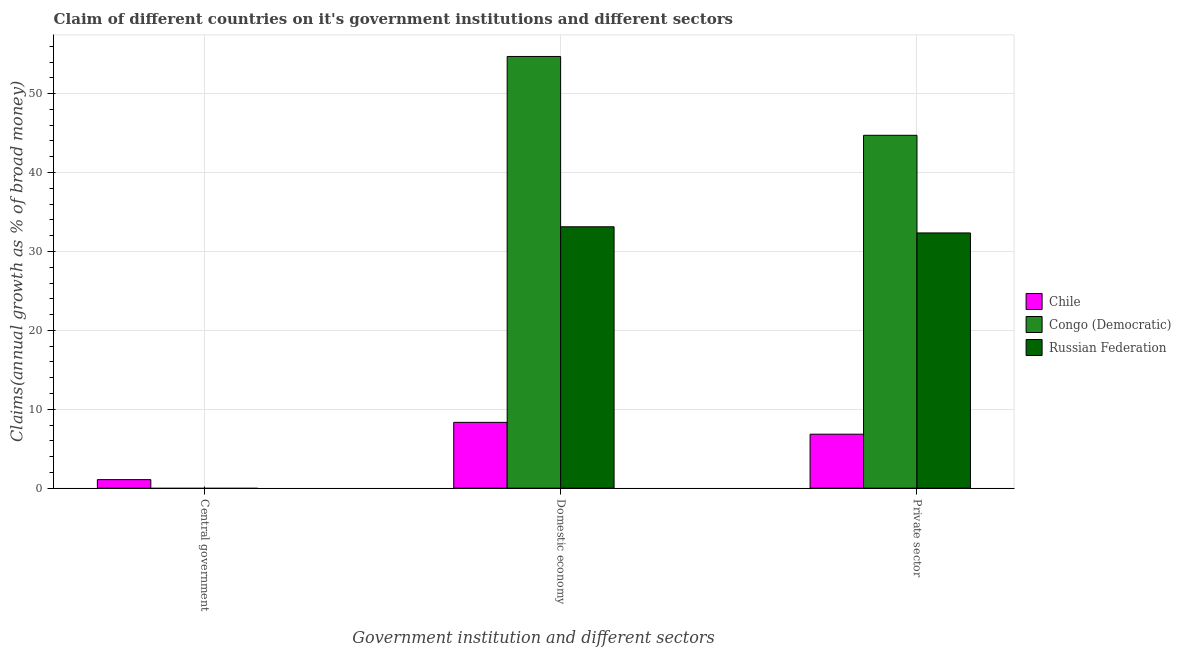Are the number of bars per tick equal to the number of legend labels?
Make the answer very short. No. What is the label of the 2nd group of bars from the left?
Provide a short and direct response. Domestic economy. What is the percentage of claim on the central government in Russian Federation?
Provide a short and direct response. 0. Across all countries, what is the maximum percentage of claim on the private sector?
Offer a very short reply. 44.72. In which country was the percentage of claim on the domestic economy maximum?
Provide a succinct answer. Congo (Democratic). What is the total percentage of claim on the domestic economy in the graph?
Your response must be concise. 96.18. What is the difference between the percentage of claim on the domestic economy in Chile and that in Congo (Democratic)?
Offer a very short reply. -46.37. What is the difference between the percentage of claim on the central government in Russian Federation and the percentage of claim on the domestic economy in Congo (Democratic)?
Your answer should be compact. -54.71. What is the average percentage of claim on the domestic economy per country?
Your response must be concise. 32.06. What is the difference between the percentage of claim on the private sector and percentage of claim on the central government in Chile?
Give a very brief answer. 5.76. In how many countries, is the percentage of claim on the central government greater than 48 %?
Keep it short and to the point. 0. What is the ratio of the percentage of claim on the domestic economy in Russian Federation to that in Congo (Democratic)?
Your answer should be very brief. 0.61. What is the difference between the highest and the second highest percentage of claim on the private sector?
Ensure brevity in your answer.  12.38. What is the difference between the highest and the lowest percentage of claim on the domestic economy?
Give a very brief answer. 46.37. Is the sum of the percentage of claim on the domestic economy in Congo (Democratic) and Russian Federation greater than the maximum percentage of claim on the central government across all countries?
Make the answer very short. Yes. Are all the bars in the graph horizontal?
Offer a very short reply. No. Does the graph contain any zero values?
Provide a succinct answer. Yes. Does the graph contain grids?
Your answer should be compact. Yes. Where does the legend appear in the graph?
Keep it short and to the point. Center right. How are the legend labels stacked?
Your answer should be very brief. Vertical. What is the title of the graph?
Offer a very short reply. Claim of different countries on it's government institutions and different sectors. What is the label or title of the X-axis?
Your response must be concise. Government institution and different sectors. What is the label or title of the Y-axis?
Your answer should be compact. Claims(annual growth as % of broad money). What is the Claims(annual growth as % of broad money) in Chile in Central government?
Provide a short and direct response. 1.08. What is the Claims(annual growth as % of broad money) in Congo (Democratic) in Central government?
Provide a short and direct response. 0. What is the Claims(annual growth as % of broad money) in Russian Federation in Central government?
Make the answer very short. 0. What is the Claims(annual growth as % of broad money) of Chile in Domestic economy?
Give a very brief answer. 8.34. What is the Claims(annual growth as % of broad money) in Congo (Democratic) in Domestic economy?
Your response must be concise. 54.71. What is the Claims(annual growth as % of broad money) in Russian Federation in Domestic economy?
Make the answer very short. 33.13. What is the Claims(annual growth as % of broad money) of Chile in Private sector?
Provide a succinct answer. 6.84. What is the Claims(annual growth as % of broad money) in Congo (Democratic) in Private sector?
Ensure brevity in your answer.  44.72. What is the Claims(annual growth as % of broad money) of Russian Federation in Private sector?
Offer a terse response. 32.34. Across all Government institution and different sectors, what is the maximum Claims(annual growth as % of broad money) in Chile?
Offer a terse response. 8.34. Across all Government institution and different sectors, what is the maximum Claims(annual growth as % of broad money) of Congo (Democratic)?
Your answer should be compact. 54.71. Across all Government institution and different sectors, what is the maximum Claims(annual growth as % of broad money) of Russian Federation?
Ensure brevity in your answer.  33.13. Across all Government institution and different sectors, what is the minimum Claims(annual growth as % of broad money) of Chile?
Ensure brevity in your answer.  1.08. Across all Government institution and different sectors, what is the minimum Claims(annual growth as % of broad money) of Congo (Democratic)?
Provide a short and direct response. 0. What is the total Claims(annual growth as % of broad money) of Chile in the graph?
Ensure brevity in your answer.  16.26. What is the total Claims(annual growth as % of broad money) in Congo (Democratic) in the graph?
Offer a terse response. 99.43. What is the total Claims(annual growth as % of broad money) in Russian Federation in the graph?
Your answer should be very brief. 65.47. What is the difference between the Claims(annual growth as % of broad money) of Chile in Central government and that in Domestic economy?
Your response must be concise. -7.26. What is the difference between the Claims(annual growth as % of broad money) in Chile in Central government and that in Private sector?
Provide a succinct answer. -5.76. What is the difference between the Claims(annual growth as % of broad money) of Chile in Domestic economy and that in Private sector?
Offer a terse response. 1.5. What is the difference between the Claims(annual growth as % of broad money) in Congo (Democratic) in Domestic economy and that in Private sector?
Offer a terse response. 9.99. What is the difference between the Claims(annual growth as % of broad money) in Russian Federation in Domestic economy and that in Private sector?
Your answer should be compact. 0.78. What is the difference between the Claims(annual growth as % of broad money) in Chile in Central government and the Claims(annual growth as % of broad money) in Congo (Democratic) in Domestic economy?
Provide a succinct answer. -53.63. What is the difference between the Claims(annual growth as % of broad money) in Chile in Central government and the Claims(annual growth as % of broad money) in Russian Federation in Domestic economy?
Your answer should be compact. -32.05. What is the difference between the Claims(annual growth as % of broad money) in Chile in Central government and the Claims(annual growth as % of broad money) in Congo (Democratic) in Private sector?
Make the answer very short. -43.64. What is the difference between the Claims(annual growth as % of broad money) in Chile in Central government and the Claims(annual growth as % of broad money) in Russian Federation in Private sector?
Keep it short and to the point. -31.26. What is the difference between the Claims(annual growth as % of broad money) of Chile in Domestic economy and the Claims(annual growth as % of broad money) of Congo (Democratic) in Private sector?
Your answer should be very brief. -36.38. What is the difference between the Claims(annual growth as % of broad money) in Chile in Domestic economy and the Claims(annual growth as % of broad money) in Russian Federation in Private sector?
Ensure brevity in your answer.  -24.01. What is the difference between the Claims(annual growth as % of broad money) of Congo (Democratic) in Domestic economy and the Claims(annual growth as % of broad money) of Russian Federation in Private sector?
Offer a terse response. 22.37. What is the average Claims(annual growth as % of broad money) in Chile per Government institution and different sectors?
Make the answer very short. 5.42. What is the average Claims(annual growth as % of broad money) in Congo (Democratic) per Government institution and different sectors?
Ensure brevity in your answer.  33.14. What is the average Claims(annual growth as % of broad money) in Russian Federation per Government institution and different sectors?
Provide a succinct answer. 21.82. What is the difference between the Claims(annual growth as % of broad money) in Chile and Claims(annual growth as % of broad money) in Congo (Democratic) in Domestic economy?
Ensure brevity in your answer.  -46.37. What is the difference between the Claims(annual growth as % of broad money) of Chile and Claims(annual growth as % of broad money) of Russian Federation in Domestic economy?
Provide a succinct answer. -24.79. What is the difference between the Claims(annual growth as % of broad money) of Congo (Democratic) and Claims(annual growth as % of broad money) of Russian Federation in Domestic economy?
Offer a terse response. 21.59. What is the difference between the Claims(annual growth as % of broad money) in Chile and Claims(annual growth as % of broad money) in Congo (Democratic) in Private sector?
Provide a succinct answer. -37.88. What is the difference between the Claims(annual growth as % of broad money) in Chile and Claims(annual growth as % of broad money) in Russian Federation in Private sector?
Provide a succinct answer. -25.51. What is the difference between the Claims(annual growth as % of broad money) of Congo (Democratic) and Claims(annual growth as % of broad money) of Russian Federation in Private sector?
Offer a terse response. 12.38. What is the ratio of the Claims(annual growth as % of broad money) of Chile in Central government to that in Domestic economy?
Your answer should be compact. 0.13. What is the ratio of the Claims(annual growth as % of broad money) of Chile in Central government to that in Private sector?
Your response must be concise. 0.16. What is the ratio of the Claims(annual growth as % of broad money) in Chile in Domestic economy to that in Private sector?
Give a very brief answer. 1.22. What is the ratio of the Claims(annual growth as % of broad money) in Congo (Democratic) in Domestic economy to that in Private sector?
Offer a terse response. 1.22. What is the ratio of the Claims(annual growth as % of broad money) of Russian Federation in Domestic economy to that in Private sector?
Ensure brevity in your answer.  1.02. What is the difference between the highest and the second highest Claims(annual growth as % of broad money) in Chile?
Provide a succinct answer. 1.5. What is the difference between the highest and the lowest Claims(annual growth as % of broad money) in Chile?
Provide a succinct answer. 7.26. What is the difference between the highest and the lowest Claims(annual growth as % of broad money) of Congo (Democratic)?
Keep it short and to the point. 54.71. What is the difference between the highest and the lowest Claims(annual growth as % of broad money) of Russian Federation?
Provide a succinct answer. 33.13. 